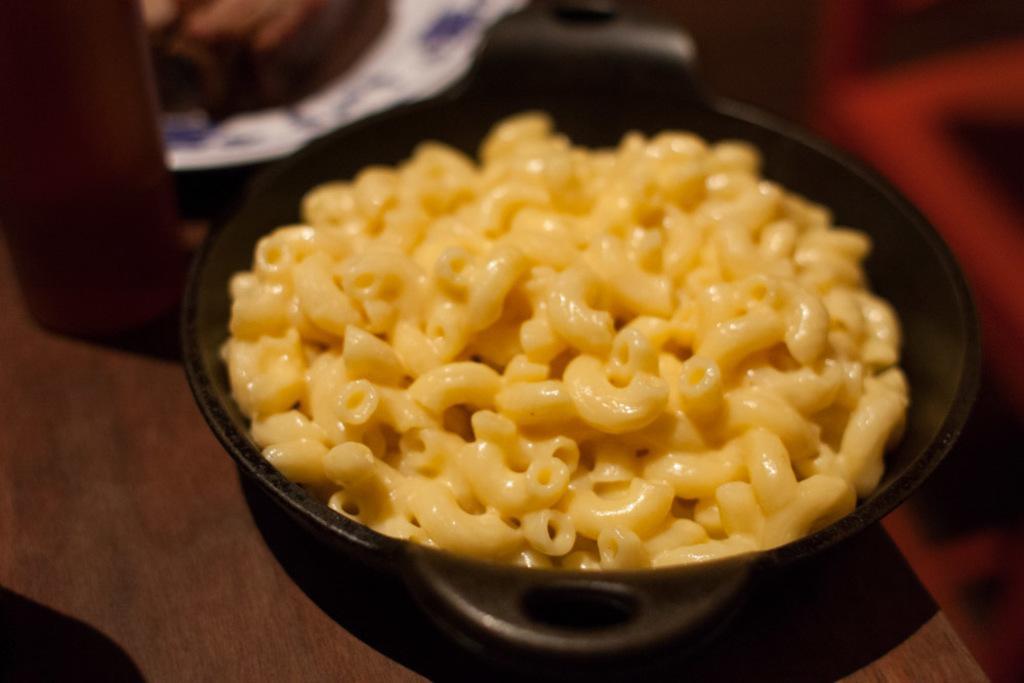Can you describe this image briefly? In this picture there is a black bowl, paper and other objects on the table. In that bowl I can see the macaronis. 